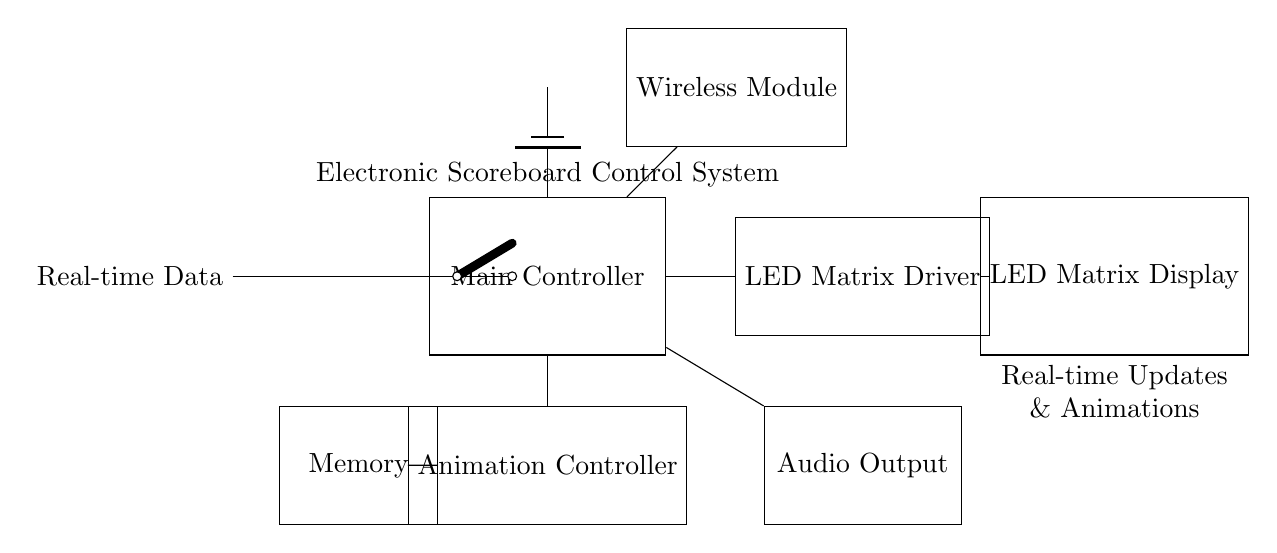What is the main component of this circuit? The main component is the Main Controller, which is centrally located in the diagram and labeled as such.
Answer: Main Controller What does the LED matrix display? The LED matrix displays real-time updates and animations, as indicated by the label beneath the LED matrix display.
Answer: Real-time updates and animations Which component provides power to the whole system? The power supply for the system is indicated by the battery symbol at the top of the Main Controller, which powers all connected components.
Answer: Battery How is real-time data fed into the circuit? Real-time data is input into the circuit through a cute open switch connected to the Main Controller, allowing for direct signals.
Answer: Open switch What is the role of the Wireless Module? The Wireless Module enables wireless communication, allowing the scoreboard to receive data updates remotely, as shown connected to the Main Controller.
Answer: Wireless communication Which component is responsible for sound output? The audio output component is responsible for sound, displayed and connected at the bottom right of the Main Controller.
Answer: Audio Output Where is the memory located in the circuit? The memory is located to the left and below the Main Controller, shown as a separate rectangular component connected to the Animation Controller.
Answer: Memory 